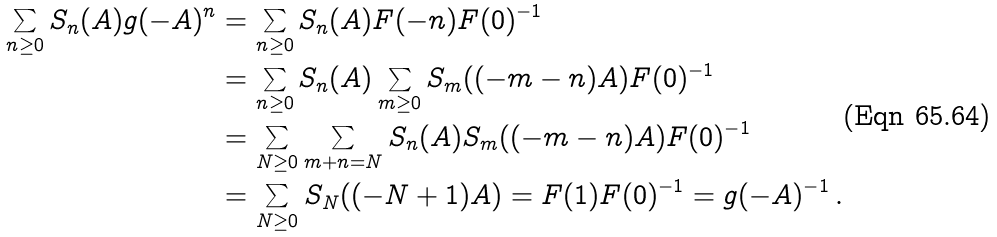Convert formula to latex. <formula><loc_0><loc_0><loc_500><loc_500>\sum _ { n \geq 0 } S _ { n } ( A ) g ( - A ) ^ { n } & = \sum _ { n \geq 0 } S _ { n } ( A ) F ( - n ) F ( 0 ) ^ { - 1 } \\ & = \sum _ { n \geq 0 } S _ { n } ( A ) \sum _ { m \geq 0 } S _ { m } ( ( - m - n ) A ) F ( 0 ) ^ { - 1 } \\ & = \sum _ { N \geq 0 } \sum _ { m + n = N } S _ { n } ( A ) S _ { m } ( ( - m - n ) A ) F ( 0 ) ^ { - 1 } \\ & = \sum _ { N \geq 0 } S _ { N } ( ( - N + 1 ) A ) = F ( 1 ) F ( 0 ) ^ { - 1 } = g ( - A ) ^ { - 1 } \, .</formula> 